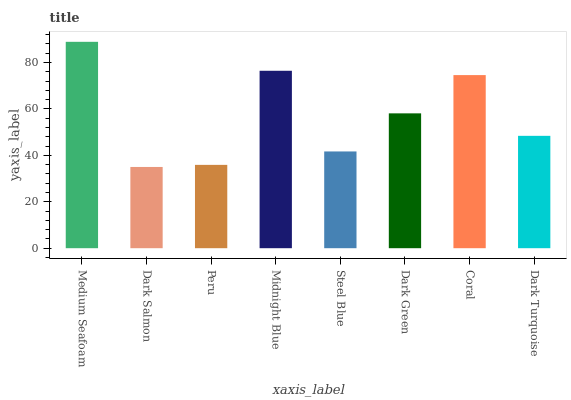Is Dark Salmon the minimum?
Answer yes or no. Yes. Is Medium Seafoam the maximum?
Answer yes or no. Yes. Is Peru the minimum?
Answer yes or no. No. Is Peru the maximum?
Answer yes or no. No. Is Peru greater than Dark Salmon?
Answer yes or no. Yes. Is Dark Salmon less than Peru?
Answer yes or no. Yes. Is Dark Salmon greater than Peru?
Answer yes or no. No. Is Peru less than Dark Salmon?
Answer yes or no. No. Is Dark Green the high median?
Answer yes or no. Yes. Is Dark Turquoise the low median?
Answer yes or no. Yes. Is Peru the high median?
Answer yes or no. No. Is Dark Green the low median?
Answer yes or no. No. 